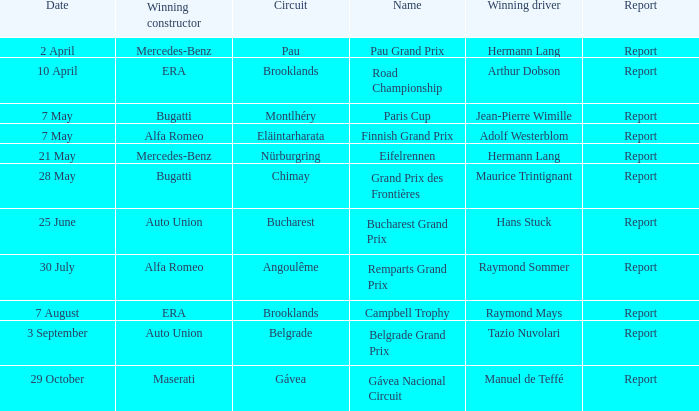Tell me the winning driver for pau grand prix Hermann Lang. 